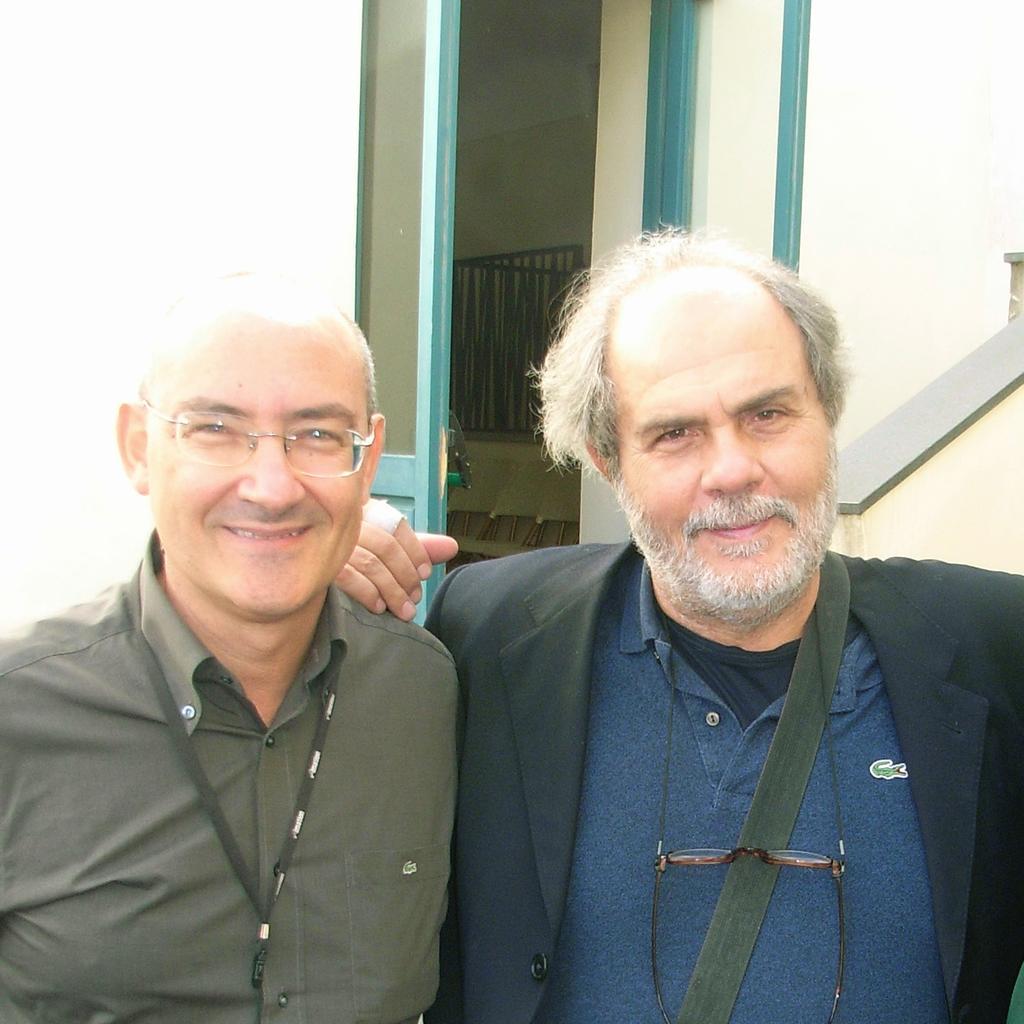Describe this image in one or two sentences. In the front of the image we can see two men are smiling. In the background of the image there are walls, door, grille and things. 